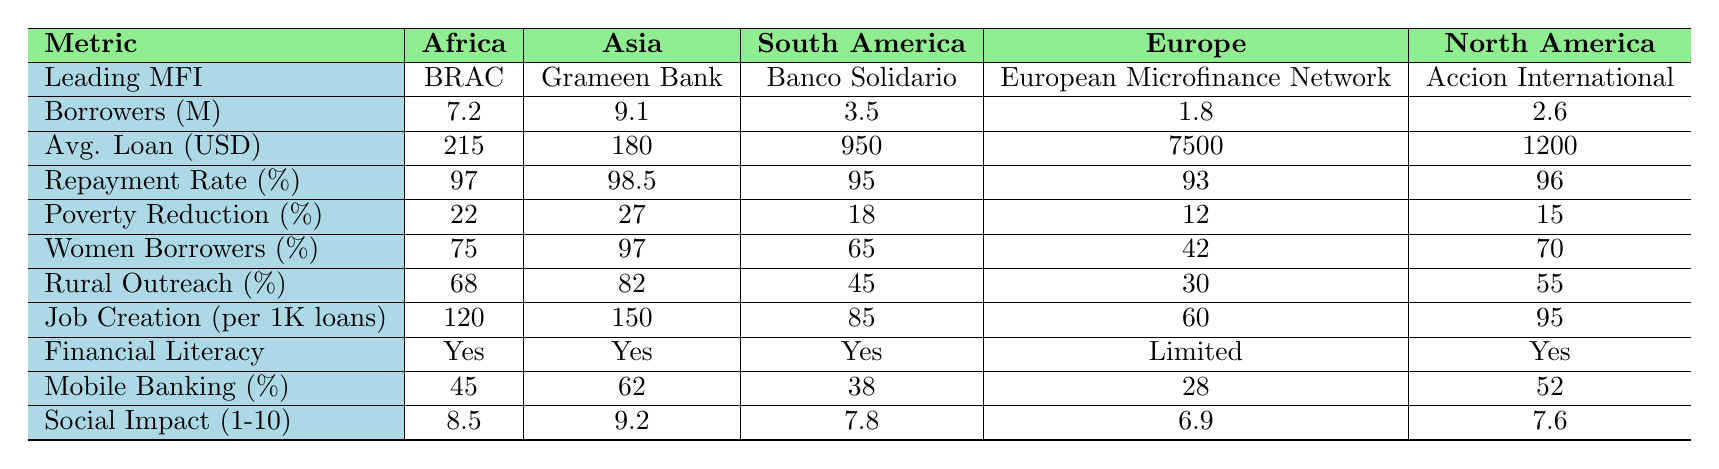What is the leading microfinance institution in Asia? The table lists the leading microfinance institution for each continent in the corresponding row. For Asia, it shows Grameen Bank.
Answer: Grameen Bank How many borrowers are there in South America? The table specifies the number of borrowers for each continent. South America has 3.5 million borrowers listed.
Answer: 3.5 million What is the average loan size in Africa? The average loan size for Africa is provided directly in the table. It shows $215 as the average loan size.
Answer: $215 Which continent has the highest repayment rate? The table shows the repayment rates for each continent, with Asia having the highest rate of 98.5%.
Answer: Asia What percentage of borrowers are women in Europe? The table indicates that 42% of borrowers in Europe are women.
Answer: 42% What is the poverty reduction impact in Africa compared to Europe? According to the table, Africa has a poverty reduction impact of 22%, while Europe has 12%. The difference is 22% - 12% = 10%.
Answer: 10% Which continent has the lowest rural outreach percentage, and what is that percentage? The table shows the rural outreach percentages for each continent. Europe has the lowest at 30%.
Answer: Europe, 30% What is the average job creation per 1,000 loans across all continents? To find the average, sum the job creations: (120 + 150 + 85 + 60 + 95) = 510. There are 5 continents, so the average is 510 / 5 = 102.
Answer: 102 Is there financial literacy program support in South America? The table shows "Yes" under financial literacy programs for South America, indicating support is available.
Answer: Yes Which continent has the highest social impact score and what is it? The social impact scores are provided in the table, with Asia showing the highest score of 9.2.
Answer: 9.2 